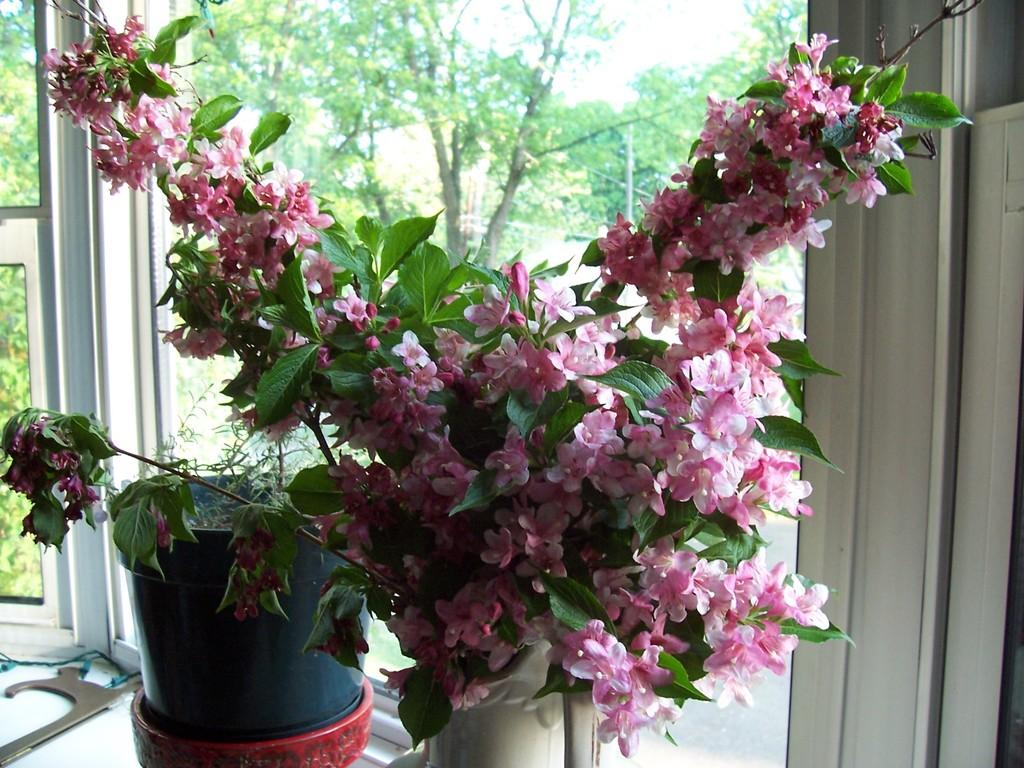What is located in the foreground of the image? There is a flower pot and plants in the foreground of the image. What can be seen through the glass window in the background? Trees and the sky are visible through the glass window in the background. What type of vegetation is present in the foreground? There are plants in the foreground of the image. What type of attraction can be seen in the image? There is no attraction present in the image; it features a flower pot, plants, a glass window, trees, and the sky. Can you tell me how many buttons are visible on the plants in the image? There are no buttons present on the plants in the image. 